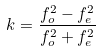Convert formula to latex. <formula><loc_0><loc_0><loc_500><loc_500>k = \frac { f _ { o } ^ { 2 } - f _ { e } ^ { 2 } } { f _ { o } ^ { 2 } + f _ { e } ^ { 2 } }</formula> 